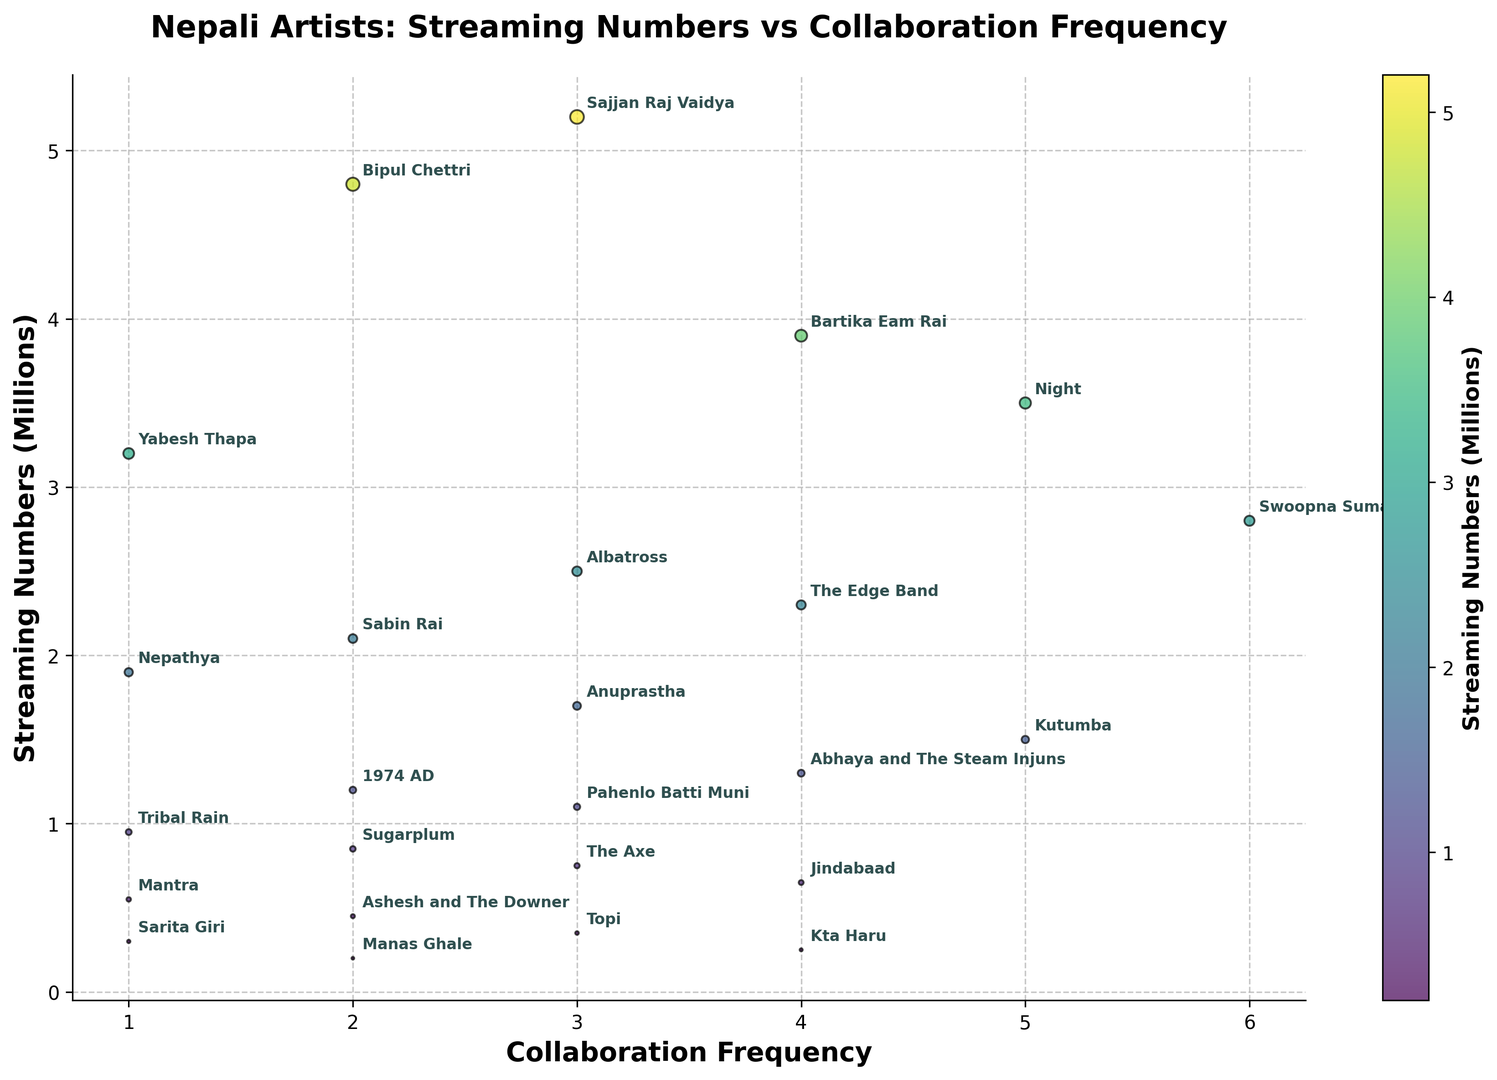Which artist has the highest streaming numbers, and how often do they collaborate? The artist with the highest streaming numbers is Sajjan Raj Vaidya, with 5.2 million streams. According to the figure, he collaborates 3 times.
Answer: Sajjan Raj Vaidya, 3 times Which artist has the lowest streaming numbers, and what is their collaboration frequency? The artist with the lowest streaming numbers is Manas Ghale, with 0.2 million streams. According to the figure, he collaborates 2 times.
Answer: Manas Ghale, 2 times Do artists with higher collaboration frequencies generally have higher streaming numbers? By observing the scatter plot, it does not appear that artists with higher collaboration frequencies necessarily have higher streaming numbers. Some artists with high collaboration frequencies have lower streaming numbers, such as Swoopna Suman, while some with low collaboration frequencies have high streaming numbers, such as Sajjan Raj Vaidya.
Answer: No Which artist has the highest collaboration frequency, and what are their streaming numbers? The artist with the highest collaboration frequency is Swoopna Suman, who collaborates 6 times. According to the figure, he has 2.8 million streaming numbers.
Answer: Swoopna Suman, 2.8 million What is the average streaming number for artists who collaborate exactly 3 times? Artists who collaborate exactly 3 times are Sajjan Raj Vaidya, Albatross, Anuprastha, Pahenlo Batti Muni, The Axe, Topi. Summing their streaming numbers: (5.2 + 2.5 + 1.7 + 1.1 + 0.75 + 0.35) million = 11.6 million. There are 6 artists, so the average is 11.6 / 6 = 1.93 million.
Answer: 1.93 million Compare the streaming numbers between artists who collaborate exactly once and those who collaborate exactly twice. Which group has the higher total streaming numbers? Artists who collaborate exactly once are Yabesh Thapa, Nepathya, Tribal Rain, Mantra, Sarita Giri. Their streaming numbers sum up to (3.2 + 1.9 + 0.95 + 0.55 + 0.3) = 6.9 million. Artists who collaborate exactly twice are Bipul Chettri, Sabin Rai, 1974 AD, Sugarplum, Ashesh and The Downer, Manas Ghale. Their streaming numbers sum up to (4.8 + 2.1 + 1.2 + 0.85 + 0.45 + 0.2) = 9.6 million. The group with collaboration frequency of 2 has higher total streaming numbers.
Answer: Artists with 2 collaborations What is the sum of the streaming numbers for artists with a collaboration frequency of 4? The artists with a collaboration frequency of 4 are Bartika Eam Rai, The Edge Band, Abhaya and The Steam Injuns, Jindabaad, Kta Haru. Summing their streaming numbers: 3.9 + 2.3 + 1.3 + 0.65 + 0.25 = 8.4 million.
Answer: 8.4 million Are there any artists with both high streaming numbers (above 3 million) and high collaboration frequency (4 or above)? By observing the scatter plot, only Bartika Eam Rai fits the criteria with streaming numbers above 3 million (3.9 million) and a collaboration frequency of 4.
Answer: Bartika Eam Rai 